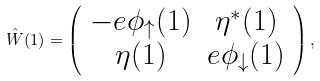<formula> <loc_0><loc_0><loc_500><loc_500>\hat { W } ( 1 ) = \left ( \begin{array} { c c } - e \phi _ { \uparrow } ( { 1 } ) & \eta ^ { * } ( { 1 } ) \\ \eta ( 1 ) & e \phi _ { \downarrow } ( { 1 } ) \end{array} \right ) ,</formula> 